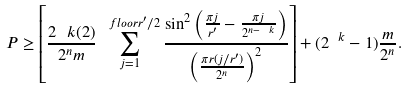Convert formula to latex. <formula><loc_0><loc_0><loc_500><loc_500>P \geq \left [ \frac { 2 ^ { \ } k ( 2 ) } { 2 ^ { n } m } \sum _ { j = 1 } ^ { \ f l o o r { r ^ { \prime } / 2 } } \frac { \sin ^ { 2 } \left ( \frac { \pi j } { r ^ { \prime } } - \frac { \pi j } { 2 ^ { n - \ k } } \right ) } { \left ( \frac { \pi r ( j / r ^ { \prime } ) } { 2 ^ { n } } \right ) ^ { 2 } } \right ] + ( 2 ^ { \ k } - 1 ) \frac { m } { 2 ^ { n } } .</formula> 